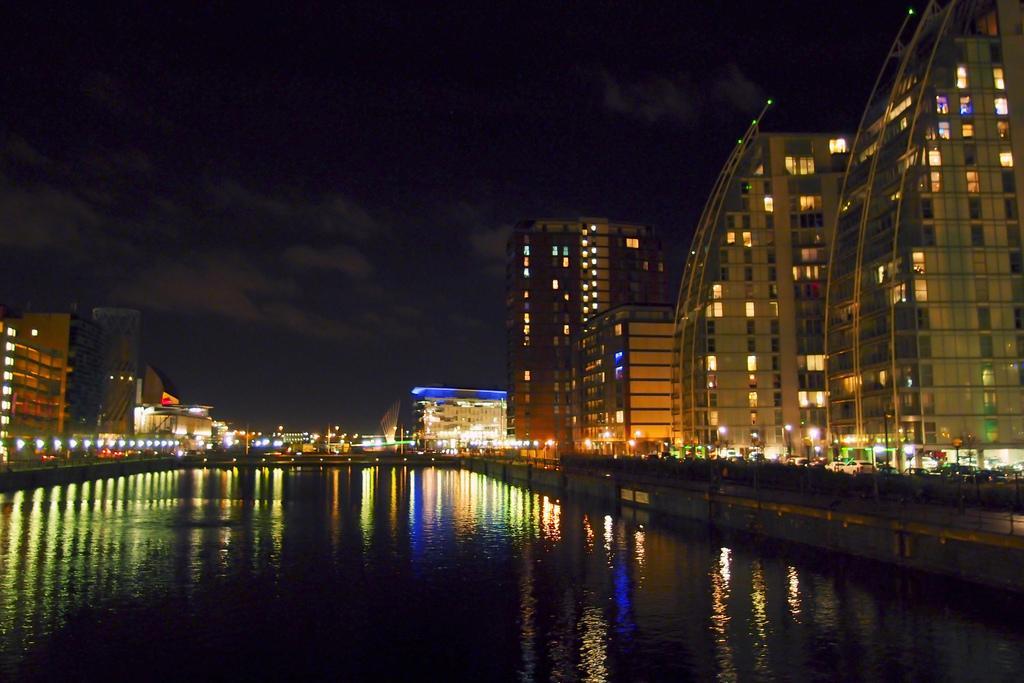Please provide a concise description of this image. In the image I can see water. On the left and right side of the image I can see buildings with colorful lights. 